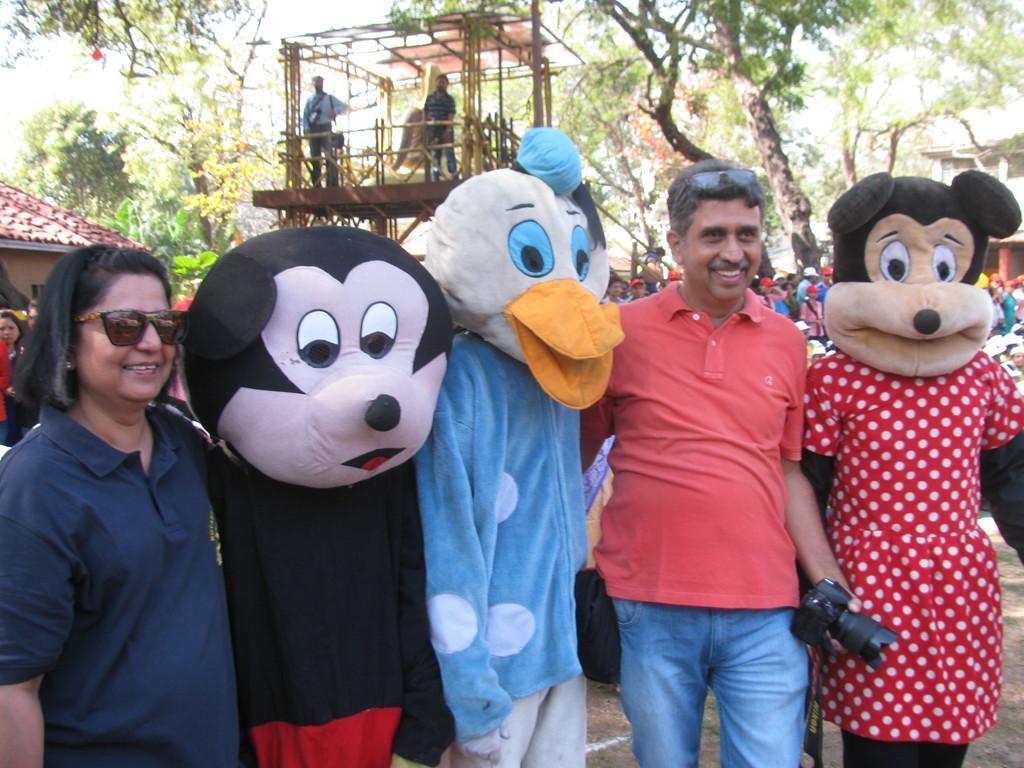In one or two sentences, can you explain what this image depicts? This picture few buildings and we see people standing and few of them wore masks and we see trees and couple of them standing on the wooden stage. 